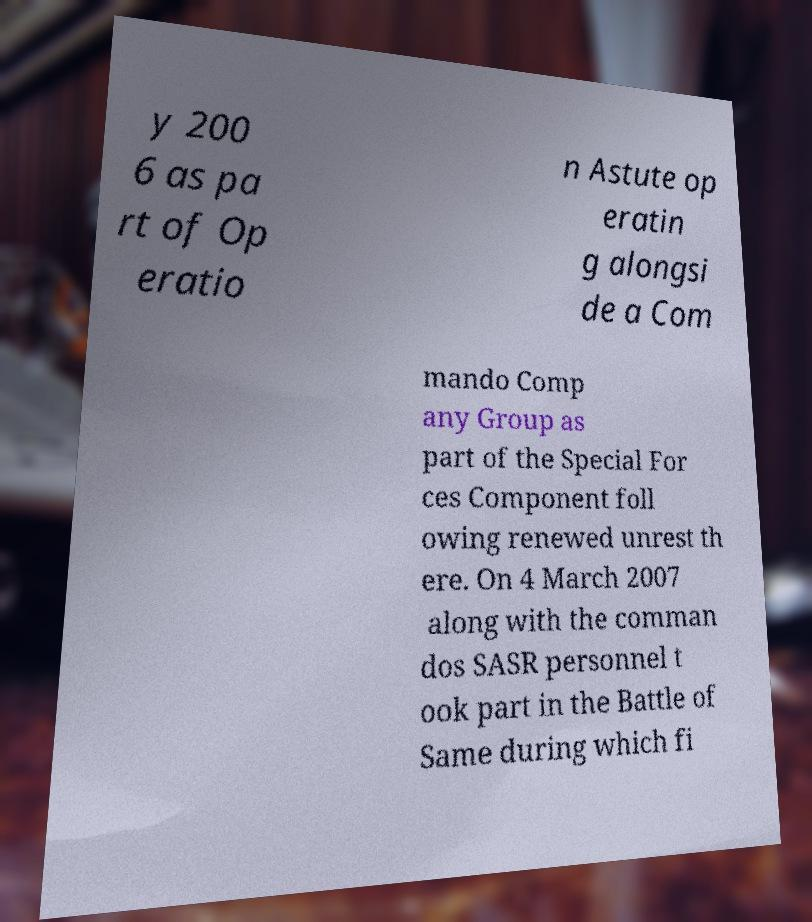Can you accurately transcribe the text from the provided image for me? y 200 6 as pa rt of Op eratio n Astute op eratin g alongsi de a Com mando Comp any Group as part of the Special For ces Component foll owing renewed unrest th ere. On 4 March 2007 along with the comman dos SASR personnel t ook part in the Battle of Same during which fi 